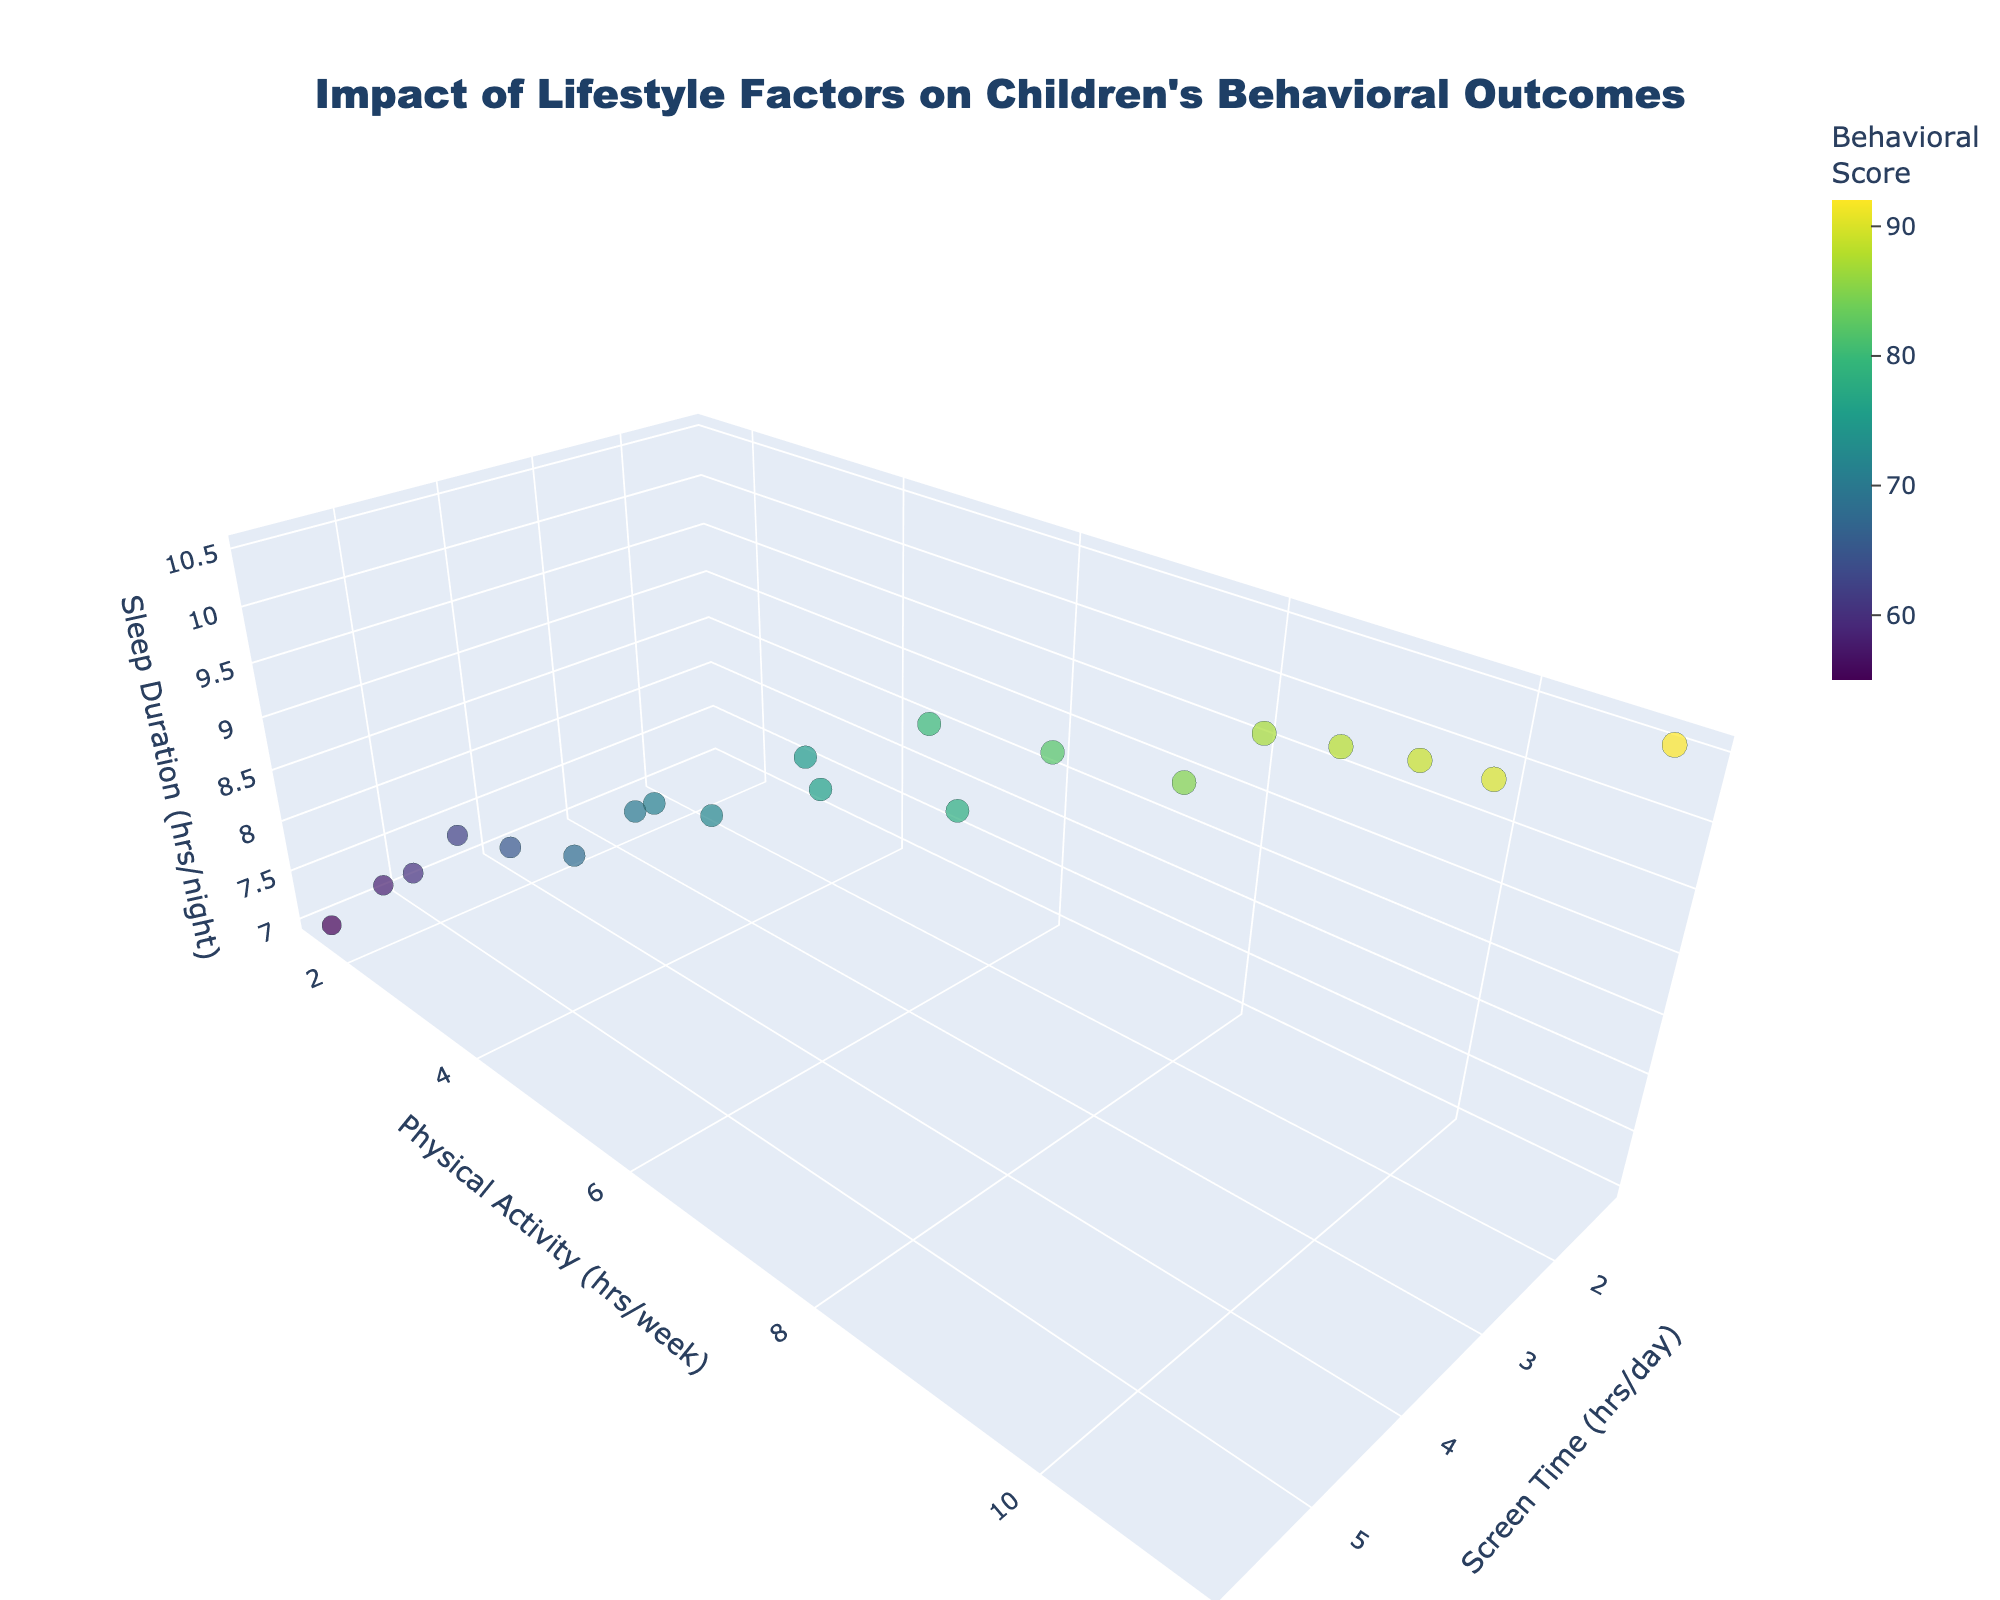What is the title of the figure? The title can be found at the top of the figure. It is in bold font and positioned in the center.
Answer: Impact of Lifestyle Factors on Children's Behavioral Outcomes How many axes are labeled, and what are their labels? The figure has a 3D plot, so there are three labeled axes: 'Screen Time (hrs/day)', 'Physical Activity (hrs/week)', and 'Sleep Duration (hrs/night)'.
Answer: 3 axes: Screen Time (hrs/day), Physical Activity (hrs/week), Sleep Duration (hrs/night) Which point has the highest Behavioral Score? Look for the data point with the largest size and darkest color (if the color scale is from light to dark) in the plot. The point with the value "Behavioral Score" as 92 will be the highest.
Answer: The point with Sleep Duration (10.5 hours/night) Is there a relationship between Screen Time and Behavioral Score? To determine the relationship, observe how the size and color of data points (which correspond to Behavioral Score) change as you move along the Screen Time axis.
Answer: Generally, as Screen Time increases, the Behavioral Score tends to decrease What is the general trend between Physical Activity and Sleep Duration? Look at the distribution of points and see if there is a noticeable pattern along the Physical Activity and Sleep Duration axes. Higher Physical Activity levels generally coincide with higher Sleep Duration values.
Answer: Higher Physical Activity corresponds to higher Sleep Duration Which axis represents the amount of physical activity children get per week? Identify the axis label that mentions physical activity.
Answer: y-axis Find the data point with 5 hours/day of Screen Time. What is the Behavioral Score at that point? Locate the point along the 'Screen Time (hrs/day)' axis where the value is 5, and check its corresponding size and color to find the corresponding Behavioral Score.
Answer: 62 Which data point has the lowest amount of screen time per day and its Behavioral Score? Find the point on the 'Screen Time (hrs/day)' axis with the smallest value.
Answer: The point with Screen Time (1.2 hours/day) has a Behavioral Score of 92 What could be the impact of decreasing screen time while maintaining high levels of physical activity on children's behavioral outcomes? Based on the distribution of data points, observe how changes in Screen Time and Physical Activity relate to Behavioral Scores. Lower screen time combined with higher physical activity generally correlates with higher Behavioral Scores.
Answer: Better behavioral outcomes Identify a point with 9.5 hours of Sleep Duration. What are the associated Screen Time, Physical Activity, and Behavioral Score for this point? Look along the 'Sleep Duration (hrs/night)' axis for the value 9.5 and note the corresponding values for 'Screen Time (hrs/day)', 'Physical Activity (hrs/week)', and 'Behavioral Score'.
Answer: Screen Time: 2.5, Physical Activity: 7, Behavioral Score: 82 